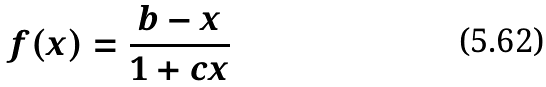Convert formula to latex. <formula><loc_0><loc_0><loc_500><loc_500>f ( x ) = \frac { b - x } { 1 + c x }</formula> 